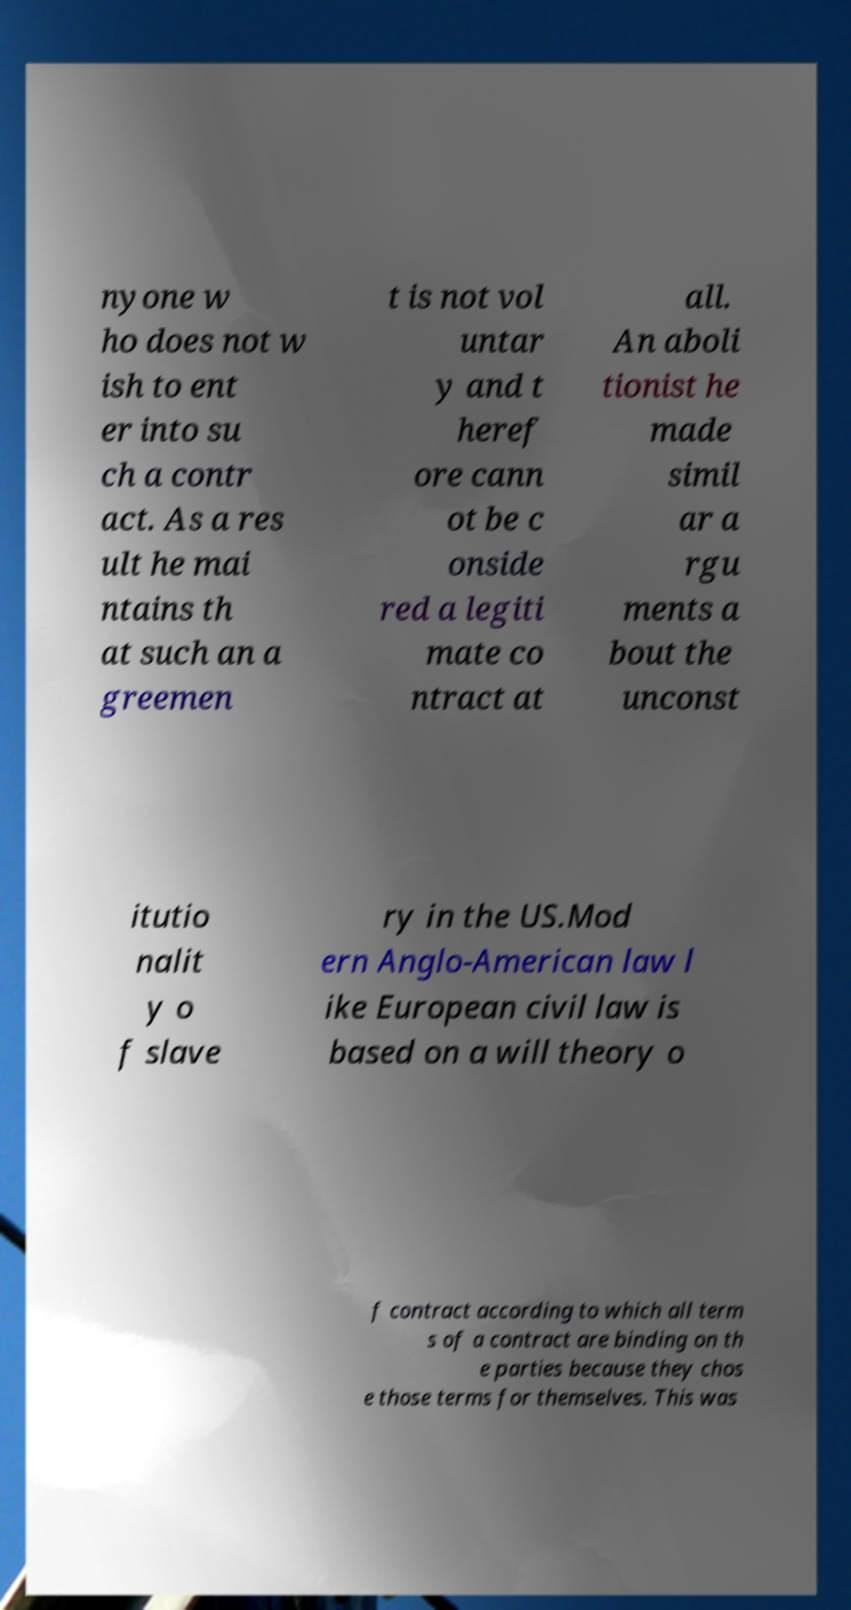For documentation purposes, I need the text within this image transcribed. Could you provide that? nyone w ho does not w ish to ent er into su ch a contr act. As a res ult he mai ntains th at such an a greemen t is not vol untar y and t heref ore cann ot be c onside red a legiti mate co ntract at all. An aboli tionist he made simil ar a rgu ments a bout the unconst itutio nalit y o f slave ry in the US.Mod ern Anglo-American law l ike European civil law is based on a will theory o f contract according to which all term s of a contract are binding on th e parties because they chos e those terms for themselves. This was 